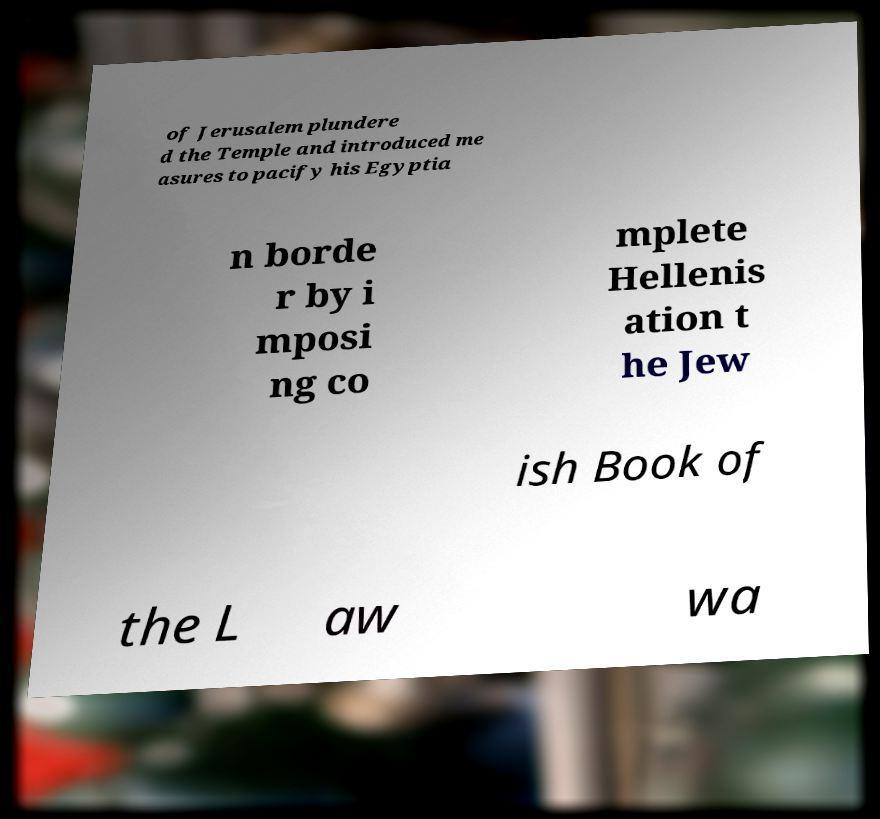Can you accurately transcribe the text from the provided image for me? of Jerusalem plundere d the Temple and introduced me asures to pacify his Egyptia n borde r by i mposi ng co mplete Hellenis ation t he Jew ish Book of the L aw wa 